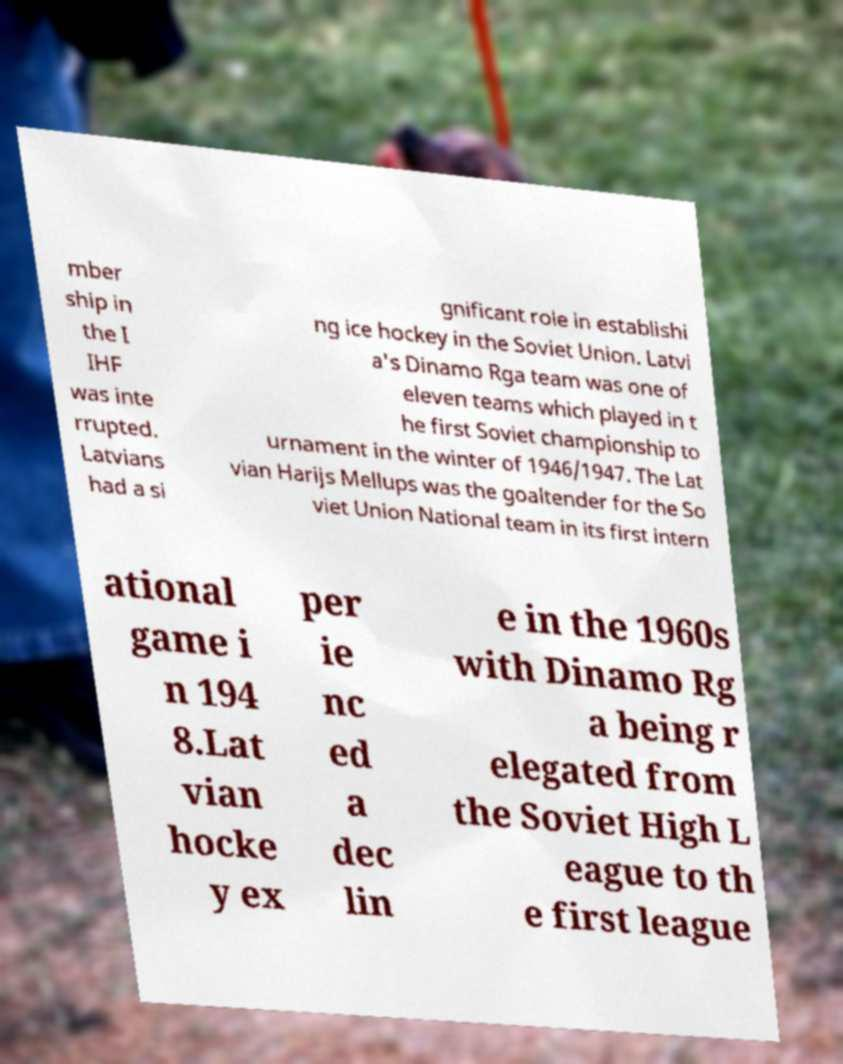Can you read and provide the text displayed in the image?This photo seems to have some interesting text. Can you extract and type it out for me? mber ship in the I IHF was inte rrupted. Latvians had a si gnificant role in establishi ng ice hockey in the Soviet Union. Latvi a's Dinamo Rga team was one of eleven teams which played in t he first Soviet championship to urnament in the winter of 1946/1947. The Lat vian Harijs Mellups was the goaltender for the So viet Union National team in its first intern ational game i n 194 8.Lat vian hocke y ex per ie nc ed a dec lin e in the 1960s with Dinamo Rg a being r elegated from the Soviet High L eague to th e first league 